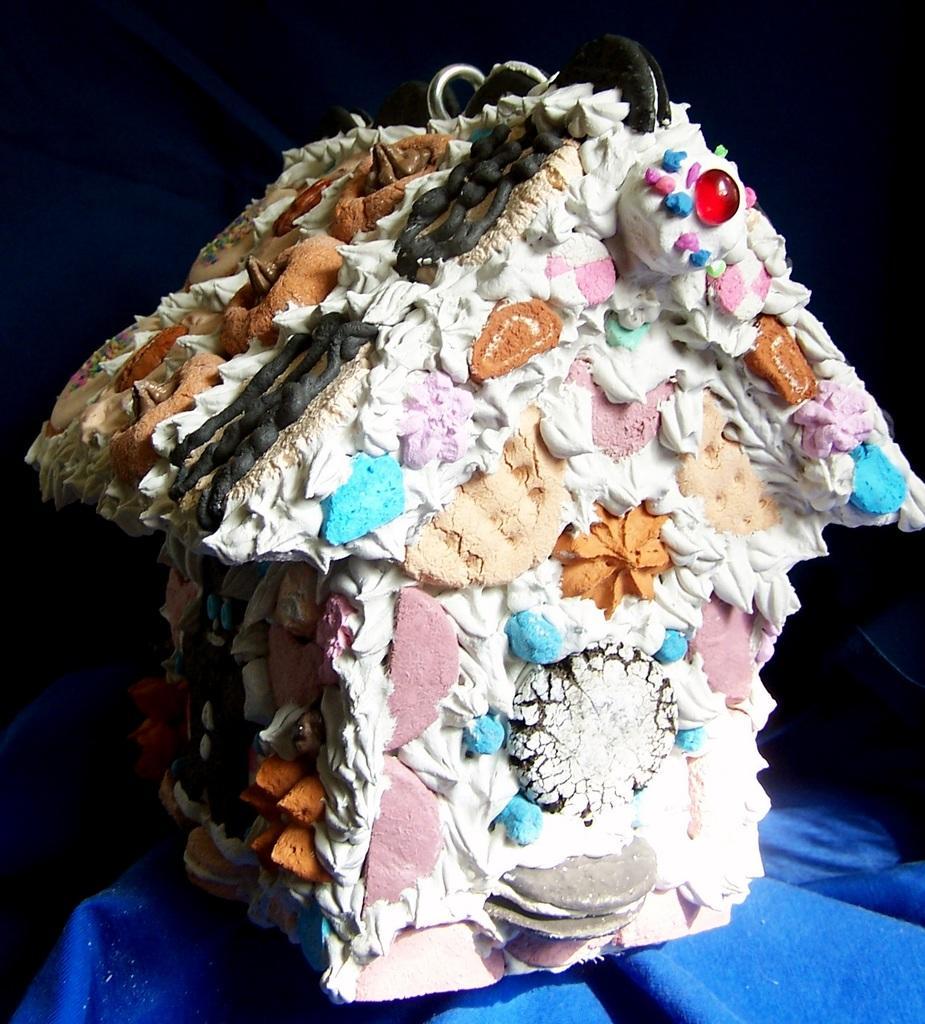Describe this image in one or two sentences. In the center of this picture we can see a white color cake which is in the shape of the house. In the foreground we can see a blue color object. 